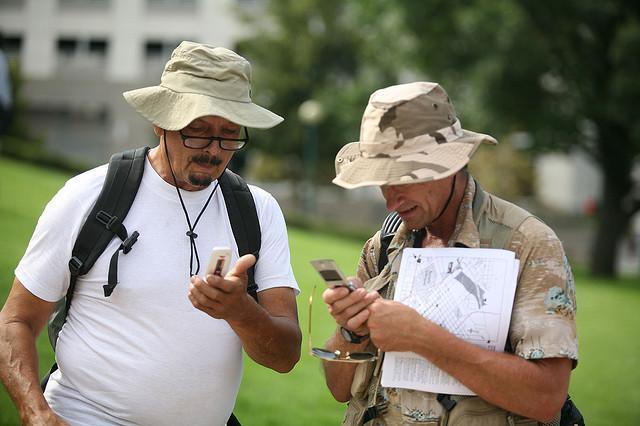How many people are visible?
Give a very brief answer. 2. How many black cats are there?
Give a very brief answer. 0. 